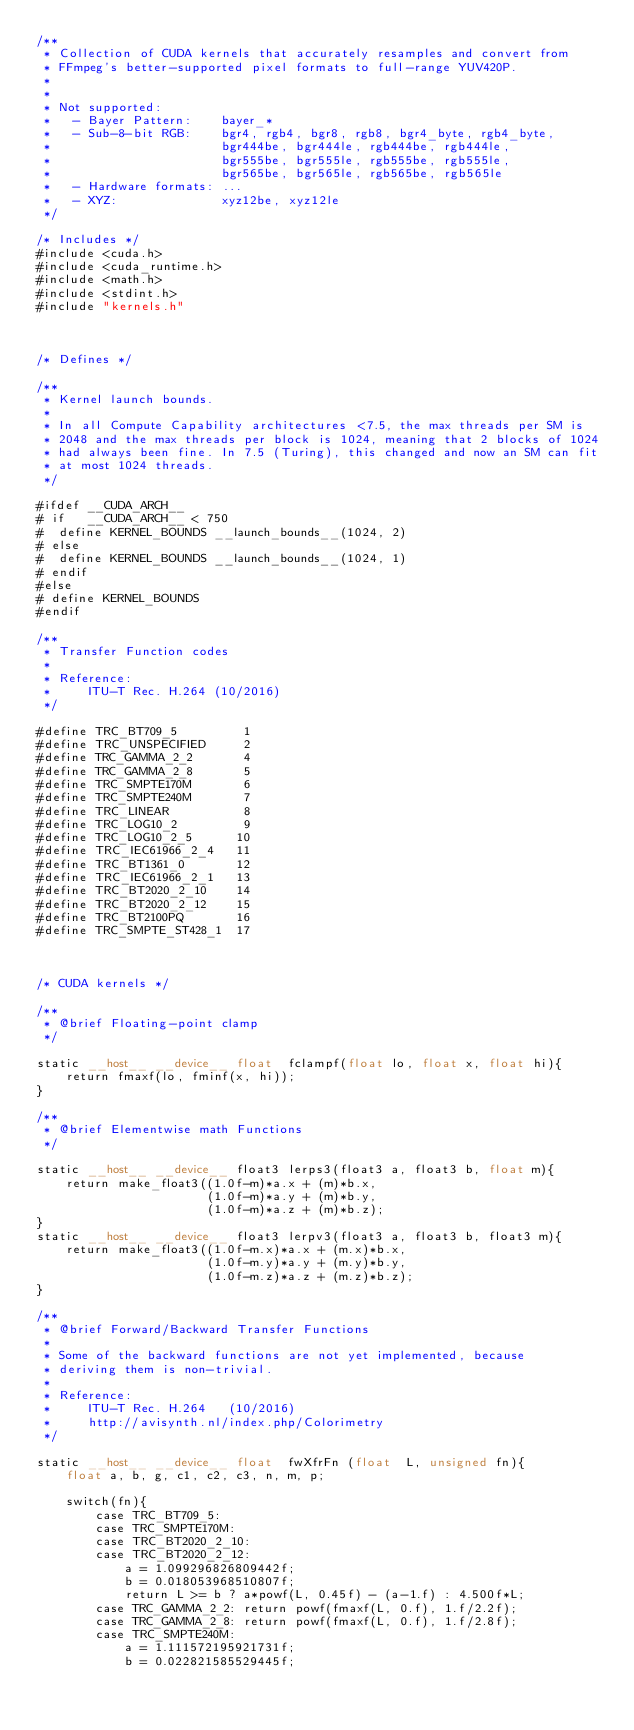Convert code to text. <code><loc_0><loc_0><loc_500><loc_500><_Cuda_>/**
 * Collection of CUDA kernels that accurately resamples and convert from
 * FFmpeg's better-supported pixel formats to full-range YUV420P.
 * 
 * 
 * Not supported:
 *   - Bayer Pattern:    bayer_*
 *   - Sub-8-bit RGB:    bgr4, rgb4, bgr8, rgb8, bgr4_byte, rgb4_byte,
 *                       bgr444be, bgr444le, rgb444be, rgb444le,
 *                       bgr555be, bgr555le, rgb555be, rgb555le,
 *                       bgr565be, bgr565le, rgb565be, rgb565le
 *   - Hardware formats: ...
 *   - XYZ:              xyz12be, xyz12le
 */

/* Includes */
#include <cuda.h>
#include <cuda_runtime.h>
#include <math.h>
#include <stdint.h>
#include "kernels.h"



/* Defines */

/**
 * Kernel launch bounds.
 * 
 * In all Compute Capability architectures <7.5, the max threads per SM is
 * 2048 and the max threads per block is 1024, meaning that 2 blocks of 1024
 * had always been fine. In 7.5 (Turing), this changed and now an SM can fit
 * at most 1024 threads.
 */

#ifdef __CUDA_ARCH__
# if   __CUDA_ARCH__ < 750
#  define KERNEL_BOUNDS __launch_bounds__(1024, 2)
# else
#  define KERNEL_BOUNDS __launch_bounds__(1024, 1)
# endif
#else
# define KERNEL_BOUNDS
#endif

/**
 * Transfer Function codes
 * 
 * Reference:
 *     ITU-T Rec. H.264 (10/2016)
 */

#define TRC_BT709_5         1
#define TRC_UNSPECIFIED     2
#define TRC_GAMMA_2_2       4
#define TRC_GAMMA_2_8       5
#define TRC_SMPTE170M       6
#define TRC_SMPTE240M       7
#define TRC_LINEAR          8
#define TRC_LOG10_2         9
#define TRC_LOG10_2_5      10
#define TRC_IEC61966_2_4   11
#define TRC_BT1361_0       12
#define TRC_IEC61966_2_1   13
#define TRC_BT2020_2_10    14
#define TRC_BT2020_2_12    15
#define TRC_BT2100PQ       16
#define TRC_SMPTE_ST428_1  17



/* CUDA kernels */

/**
 * @brief Floating-point clamp
 */

static __host__ __device__ float  fclampf(float lo, float x, float hi){
    return fmaxf(lo, fminf(x, hi));
}

/**
 * @brief Elementwise math Functions
 */

static __host__ __device__ float3 lerps3(float3 a, float3 b, float m){
    return make_float3((1.0f-m)*a.x + (m)*b.x,
                       (1.0f-m)*a.y + (m)*b.y,
                       (1.0f-m)*a.z + (m)*b.z);
}
static __host__ __device__ float3 lerpv3(float3 a, float3 b, float3 m){
    return make_float3((1.0f-m.x)*a.x + (m.x)*b.x,
                       (1.0f-m.y)*a.y + (m.y)*b.y,
                       (1.0f-m.z)*a.z + (m.z)*b.z);
}

/**
 * @brief Forward/Backward Transfer Functions
 * 
 * Some of the backward functions are not yet implemented, because
 * deriving them is non-trivial.
 * 
 * Reference:
 *     ITU-T Rec. H.264   (10/2016)
 *     http://avisynth.nl/index.php/Colorimetry
 */

static __host__ __device__ float  fwXfrFn (float  L, unsigned fn){
    float a, b, g, c1, c2, c3, n, m, p;
    
    switch(fn){
        case TRC_BT709_5:
        case TRC_SMPTE170M:
        case TRC_BT2020_2_10:
        case TRC_BT2020_2_12:
            a = 1.099296826809442f;
            b = 0.018053968510807f;
            return L >= b ? a*powf(L, 0.45f) - (a-1.f) : 4.500f*L;
        case TRC_GAMMA_2_2: return powf(fmaxf(L, 0.f), 1.f/2.2f);
        case TRC_GAMMA_2_8: return powf(fmaxf(L, 0.f), 1.f/2.8f);
        case TRC_SMPTE240M:
            a = 1.111572195921731f;
            b = 0.022821585529445f;</code> 